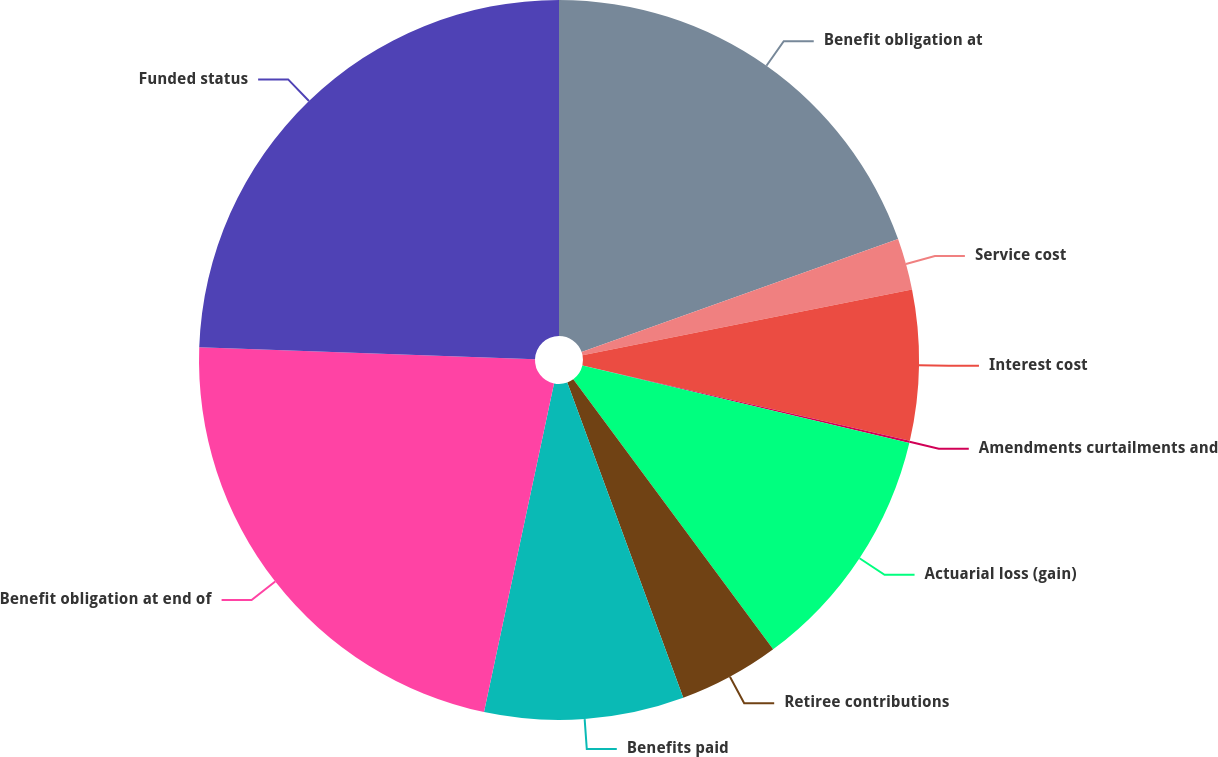<chart> <loc_0><loc_0><loc_500><loc_500><pie_chart><fcel>Benefit obligation at<fcel>Service cost<fcel>Interest cost<fcel>Amendments curtailments and<fcel>Actuarial loss (gain)<fcel>Retiree contributions<fcel>Benefits paid<fcel>Benefit obligation at end of<fcel>Funded status<nl><fcel>19.55%<fcel>2.31%<fcel>6.74%<fcel>0.1%<fcel>11.16%<fcel>4.53%<fcel>8.95%<fcel>22.22%<fcel>24.44%<nl></chart> 